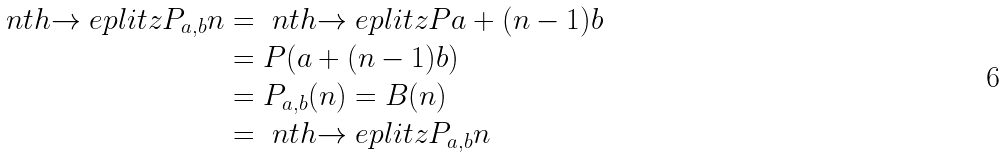<formula> <loc_0><loc_0><loc_500><loc_500>\ n t h { \to e p l i t z { P } _ { a , b } } { n } & = \ n t h { \to e p l i t z { P } } { a + ( n - 1 ) b } \\ & = P ( a + ( n - 1 ) b ) \\ & = P _ { a , b } ( n ) = B ( n ) \\ & = \ n t h { \to e p l i t z { P _ { a , b } } } { n }</formula> 